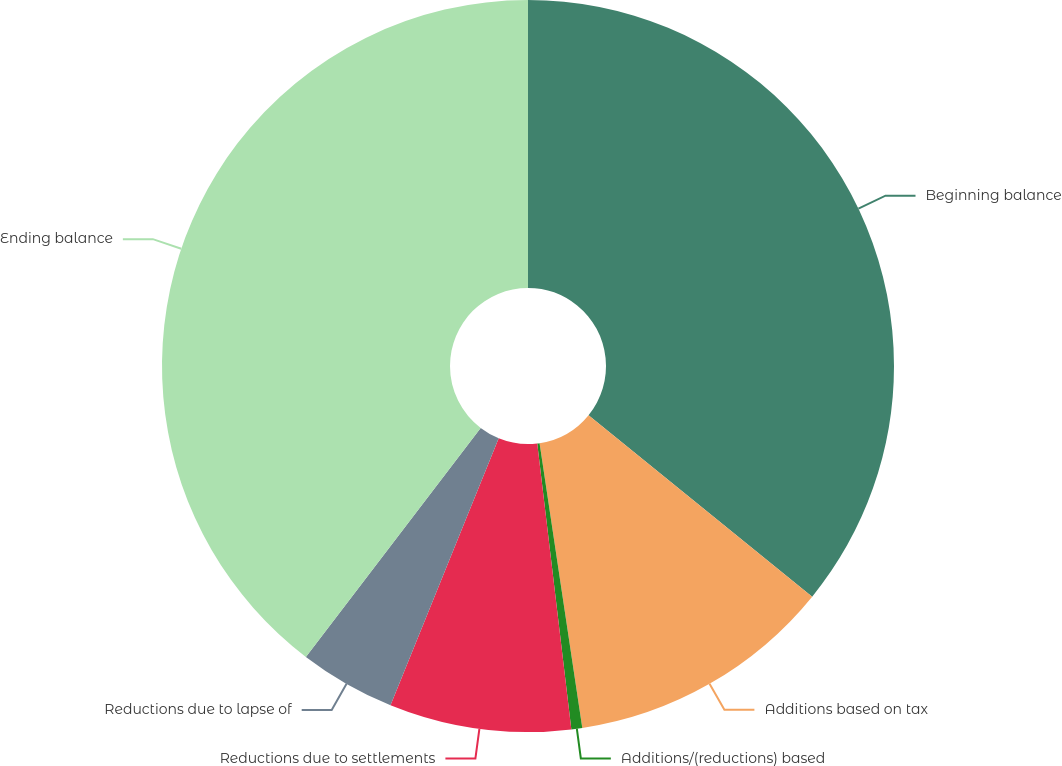<chart> <loc_0><loc_0><loc_500><loc_500><pie_chart><fcel>Beginning balance<fcel>Additions based on tax<fcel>Additions/(reductions) based<fcel>Reductions due to settlements<fcel>Reductions due to lapse of<fcel>Ending balance<nl><fcel>35.85%<fcel>11.78%<fcel>0.48%<fcel>8.02%<fcel>4.25%<fcel>39.62%<nl></chart> 